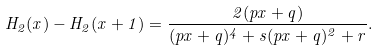Convert formula to latex. <formula><loc_0><loc_0><loc_500><loc_500>H _ { 2 } ( x ) - H _ { 2 } ( x + 1 ) = \frac { 2 ( p x + q ) } { ( p x + q ) ^ { 4 } + s ( p x + q ) ^ { 2 } + r } .</formula> 